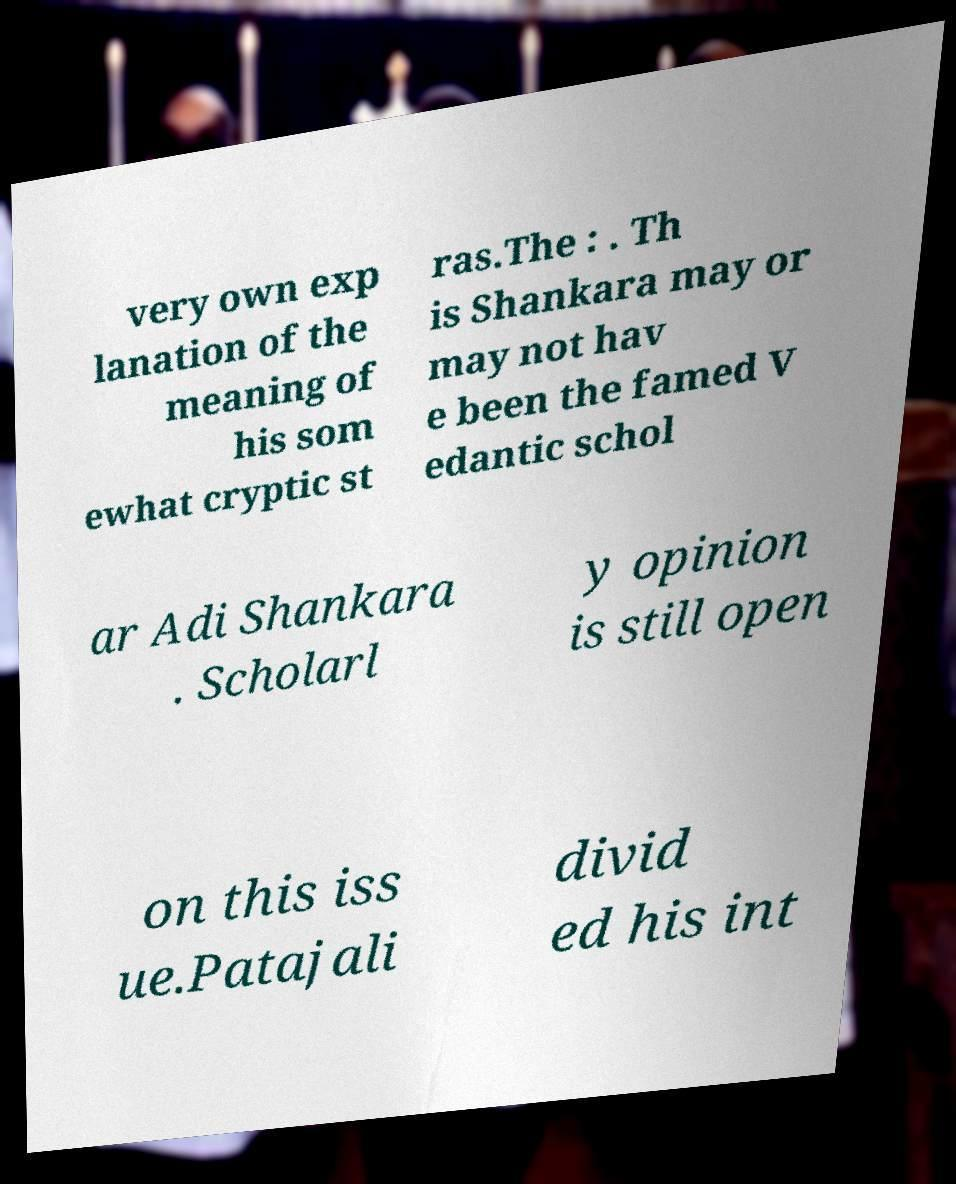Could you extract and type out the text from this image? very own exp lanation of the meaning of his som ewhat cryptic st ras.The : . Th is Shankara may or may not hav e been the famed V edantic schol ar Adi Shankara . Scholarl y opinion is still open on this iss ue.Patajali divid ed his int 